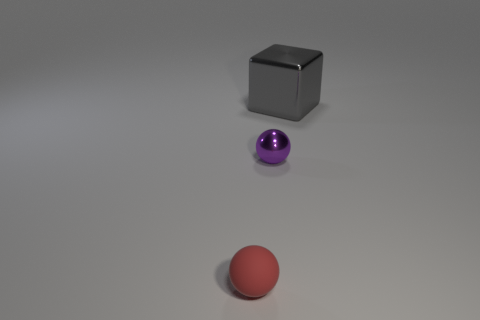Add 3 large cyan metal objects. How many objects exist? 6 Subtract all balls. How many objects are left? 1 Add 2 big blue metallic cylinders. How many big blue metallic cylinders exist? 2 Subtract 1 red spheres. How many objects are left? 2 Subtract all big gray shiny blocks. Subtract all tiny yellow shiny cubes. How many objects are left? 2 Add 3 red matte objects. How many red matte objects are left? 4 